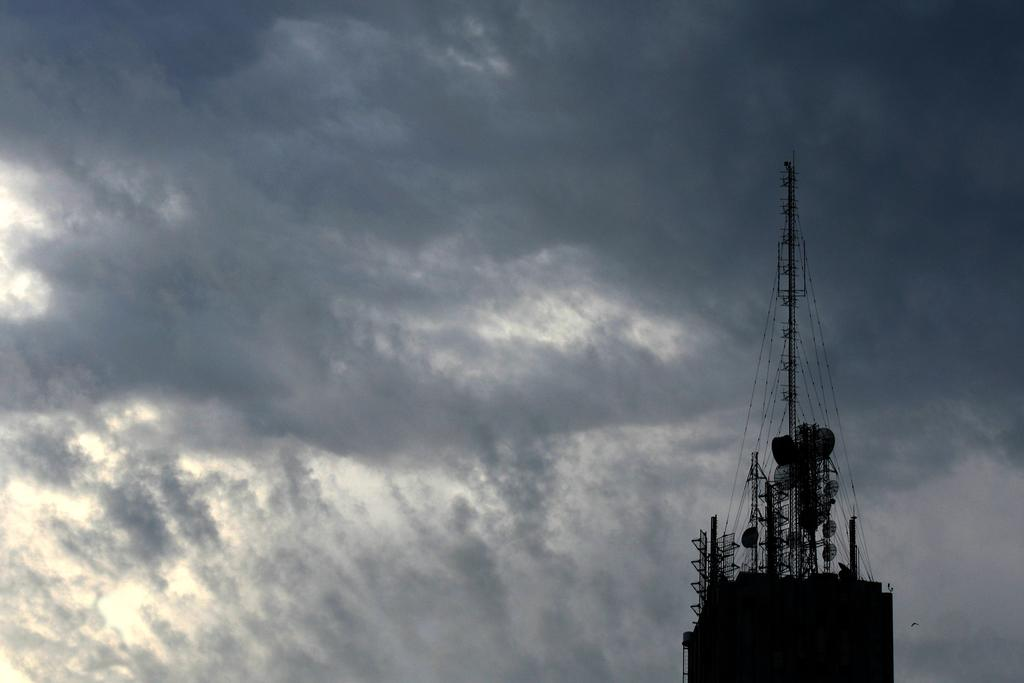What structures are present in the picture? There are towers in the picture. What can be seen in the background of the picture? The sky is visible in the background of the picture. Where is the oatmeal being served in the picture? There is no oatmeal present in the picture. What type of furniture is the person sitting on in the picture? There is no person or furniture visible in the picture; it only features towers and the sky. 